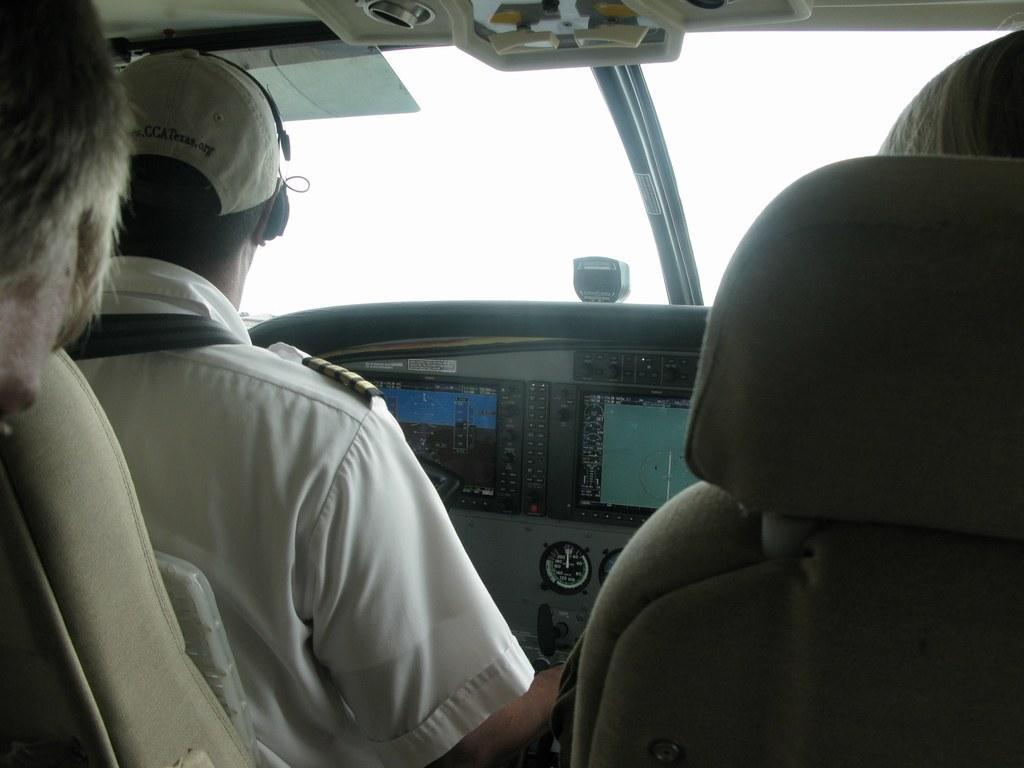Could you give a brief overview of what you see in this image? This is an inside view of a vehicle. Here I can see a person wearing a white color shirt, cap on the head and sitting on a seat facing towards the back side. In front of this person there are few devices and also there is a glass. On the right side there is another seat. 